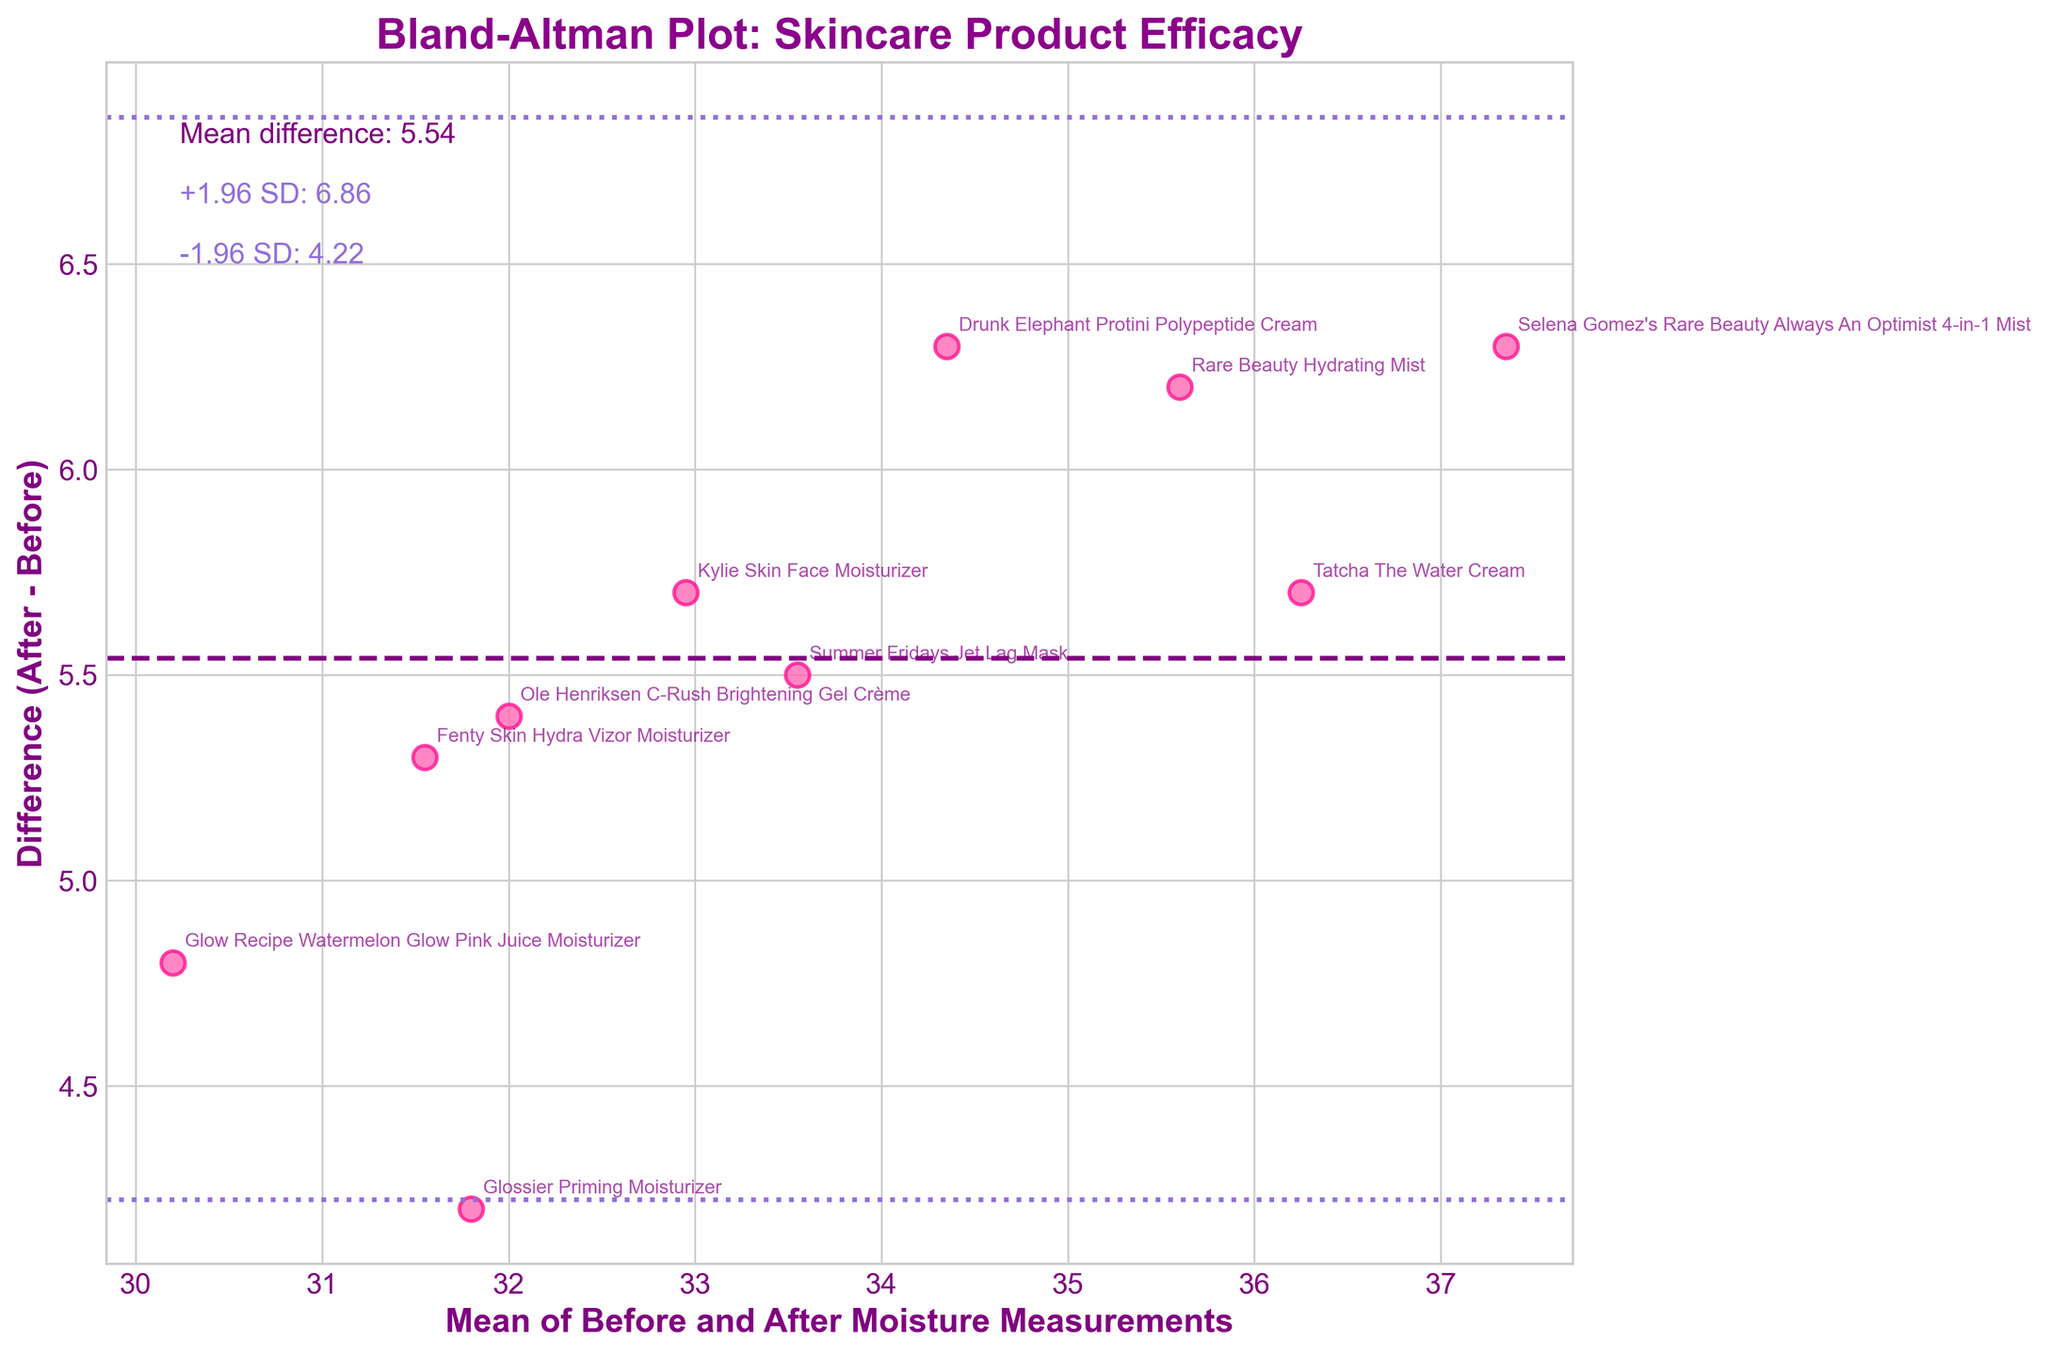What's the title of the plot? Looking at the top of the figure, the title is usually found there. In this case, it reads "Bland-Altman Plot: Skincare Product Efficacy".
Answer: Bland-Altman Plot: Skincare Product Efficacy How many axes are there in the plot? Usually, a plot has two axes. In this figure, one is the horizontal (x-axis) and the other is the vertical (y-axis).
Answer: 2 What do the axes represent? The x-axis label shows "Mean of Before and After Moisture Measurements", and the y-axis label shows "Difference (After - Before)".
Answer: Mean of Before and After Moisture Measurements and Difference (After - Before) What is the mean difference represented by the dashed line? The dashed line represents the mean difference, as annotated in the top left of the figure. The mean difference is labeled as 5.11.
Answer: 5.11 Which product showed the highest increase in moisture? To find the highest increase, look for the data point with the highest position on the y-axis (Difference). "Selena Gomez's Rare Beauty Always An Optimist 4-in-1 Mist" is the highest.
Answer: Selena Gomez's Rare Beauty Always An Optimist 4-in-1 Mist What is the mean value of moisture before and after for "Selena Gomez's Rare Beauty Always An Optimist 4-in-1 Mist"? The mean value can be calculated by taking the average of the "Before" and "After" values: (34.2 + 40.5) / 2 = 37.35.
Answer: 37.35 By how much does the "Glow Recipe Watermelon Glow Pink Juice Moisturizer" improve the skin moisture? You find the difference between the "After" and "Before" values: 32.6 - 27.8 = 4.8.
Answer: 4.8 What is the standard deviation of the differences, as suggested by the lines at ±1.96 SD from the mean? The lines at ±1.96 standard deviations (SD) are annotated with values 11.43 and -1.21, implying that the standard deviation is (11.43 - 5.11) / 1.96 ≈ 3.23.
Answer: 3.23 How does the moisture improvement variability compare across products? The variability can be understood by the spread of points around the mean difference line. Points far from the mean difference line indicate higher variability; points close indicate lower variability.
Answer: Varies Which product has the closest mean moisture value to 35? By finding the data point whose mean is closest to 35, the "Drunk Elephant Protini Polypeptide Cream", with a mean moisture of (31.2 + 37.5) / 2 = 34.35, is close to 35.
Answer: Drunk Elephant Protini Polypeptide Cream 